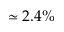<formula> <loc_0><loc_0><loc_500><loc_500>\simeq 2 . 4 \%</formula> 